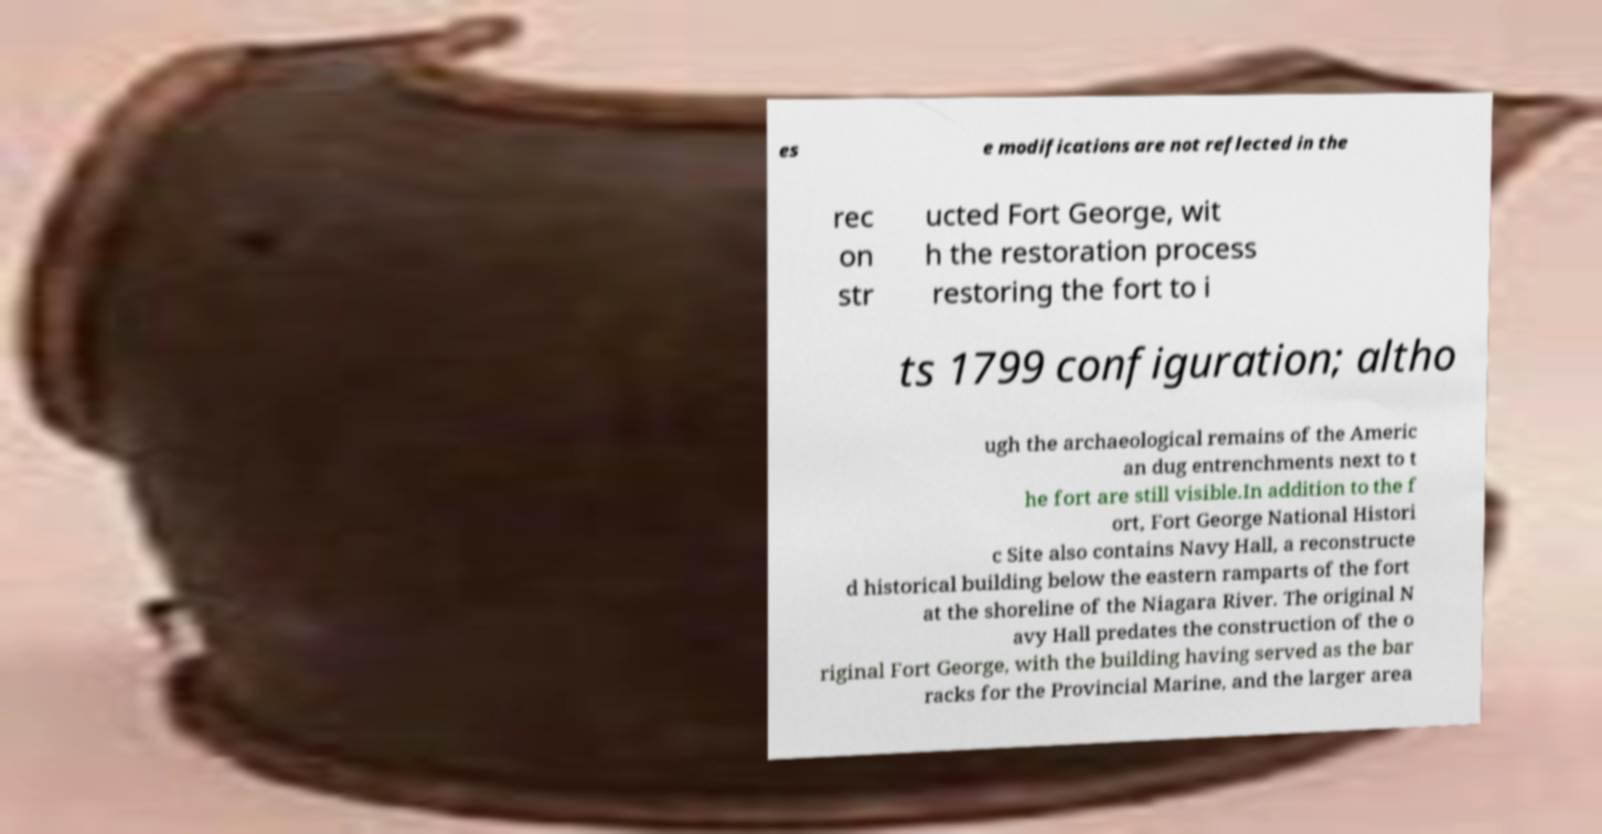Please identify and transcribe the text found in this image. es e modifications are not reflected in the rec on str ucted Fort George, wit h the restoration process restoring the fort to i ts 1799 configuration; altho ugh the archaeological remains of the Americ an dug entrenchments next to t he fort are still visible.In addition to the f ort, Fort George National Histori c Site also contains Navy Hall, a reconstructe d historical building below the eastern ramparts of the fort at the shoreline of the Niagara River. The original N avy Hall predates the construction of the o riginal Fort George, with the building having served as the bar racks for the Provincial Marine, and the larger area 